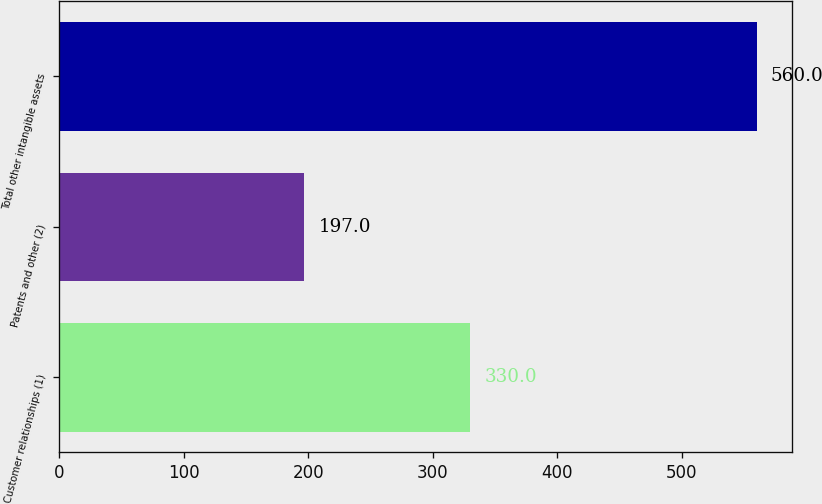Convert chart to OTSL. <chart><loc_0><loc_0><loc_500><loc_500><bar_chart><fcel>Customer relationships (1)<fcel>Patents and other (2)<fcel>Total other intangible assets<nl><fcel>330<fcel>197<fcel>560<nl></chart> 